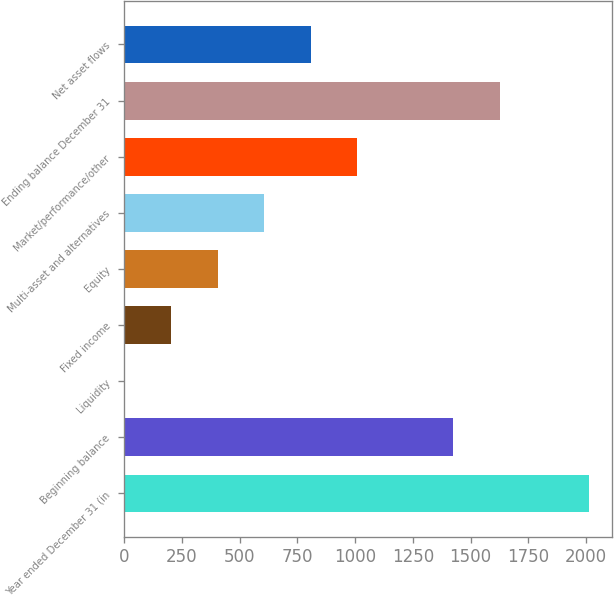<chart> <loc_0><loc_0><loc_500><loc_500><bar_chart><fcel>Year ended December 31 (in<fcel>Beginning balance<fcel>Liquidity<fcel>Fixed income<fcel>Equity<fcel>Multi-asset and alternatives<fcel>Market/performance/other<fcel>Ending balance December 31<fcel>Net asset flows<nl><fcel>2013<fcel>1426<fcel>4<fcel>204.9<fcel>405.8<fcel>606.7<fcel>1008.5<fcel>1626.9<fcel>807.6<nl></chart> 